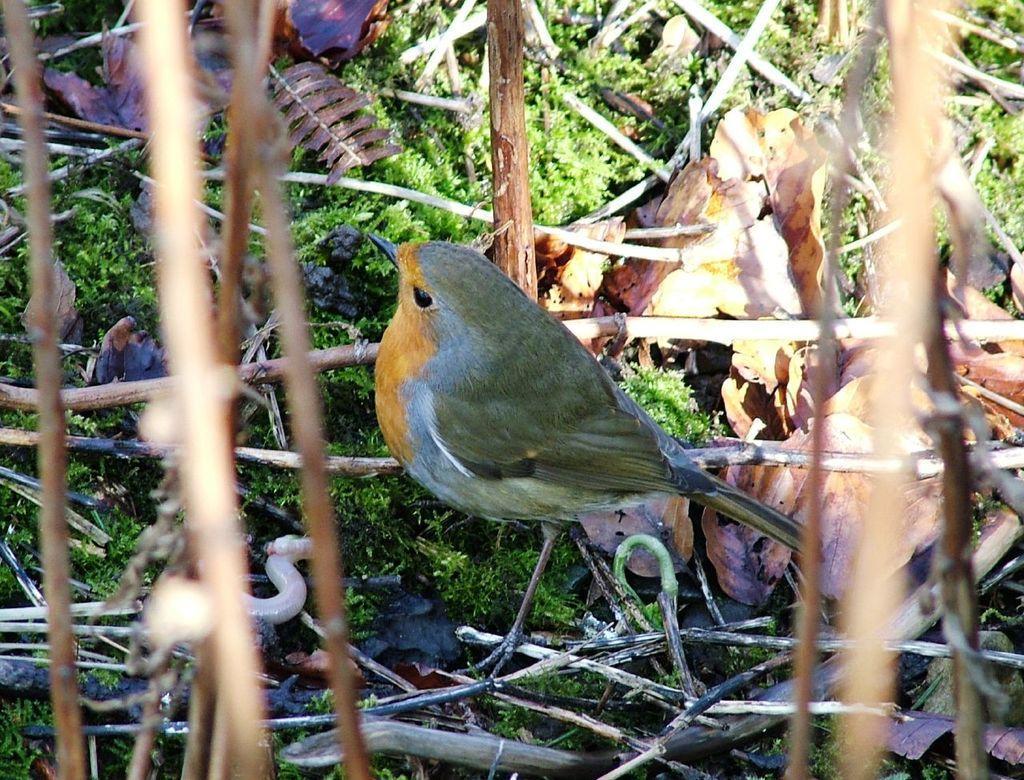How would you summarize this image in a sentence or two? In this image in the center there is one bird and also there are some wooden sticks, dry leaves and some scrap. At the bottom there is grass. 